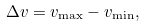<formula> <loc_0><loc_0><loc_500><loc_500>\Delta v = v _ { \max } - v _ { \min } ,</formula> 